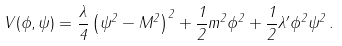<formula> <loc_0><loc_0><loc_500><loc_500>V ( \phi , \psi ) = \frac { \lambda } { 4 } \left ( \psi ^ { 2 } - M ^ { 2 } \right ) ^ { 2 } + \frac { 1 } { 2 } m ^ { 2 } \phi ^ { 2 } + \frac { 1 } { 2 } \lambda ^ { \prime } \phi ^ { 2 } \psi ^ { 2 } \, .</formula> 